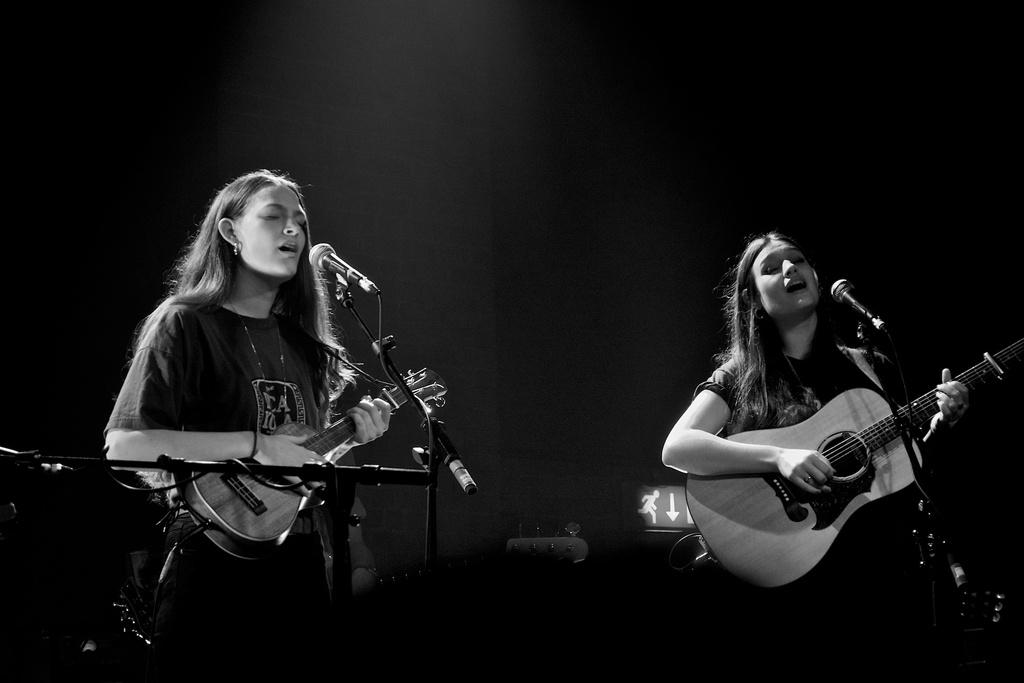What are the girls in the image doing? The girls in the image are playing guitar. What object is present that might be used for amplifying their voices? There is a microphone in the image. What type of grain is being processed in the image? There is no grain or processing activity present in the image. How many cakes are visible on the table in the image? There are no cakes present in the image. 